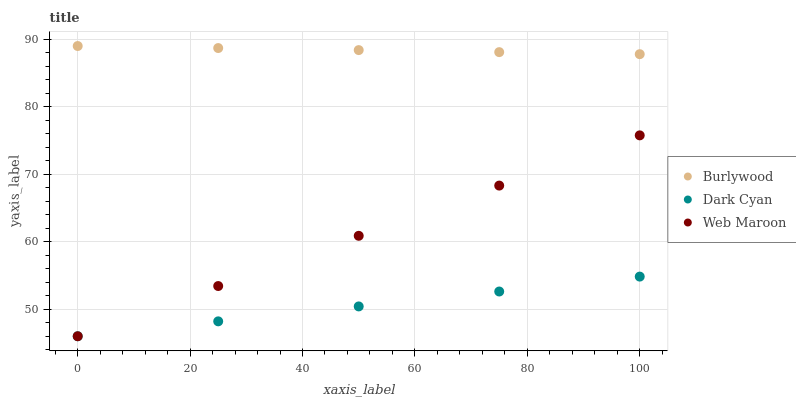Does Dark Cyan have the minimum area under the curve?
Answer yes or no. Yes. Does Burlywood have the maximum area under the curve?
Answer yes or no. Yes. Does Web Maroon have the minimum area under the curve?
Answer yes or no. No. Does Web Maroon have the maximum area under the curve?
Answer yes or no. No. Is Dark Cyan the smoothest?
Answer yes or no. Yes. Is Burlywood the roughest?
Answer yes or no. Yes. Is Web Maroon the roughest?
Answer yes or no. No. Does Dark Cyan have the lowest value?
Answer yes or no. Yes. Does Burlywood have the highest value?
Answer yes or no. Yes. Does Web Maroon have the highest value?
Answer yes or no. No. Is Web Maroon less than Burlywood?
Answer yes or no. Yes. Is Burlywood greater than Web Maroon?
Answer yes or no. Yes. Does Web Maroon intersect Dark Cyan?
Answer yes or no. Yes. Is Web Maroon less than Dark Cyan?
Answer yes or no. No. Is Web Maroon greater than Dark Cyan?
Answer yes or no. No. Does Web Maroon intersect Burlywood?
Answer yes or no. No. 